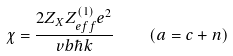Convert formula to latex. <formula><loc_0><loc_0><loc_500><loc_500>\chi = \frac { 2 Z _ { X } Z _ { e f f } ^ { ( 1 ) } e ^ { 2 } } { v b \hbar { k } } \quad ( a = c + n )</formula> 